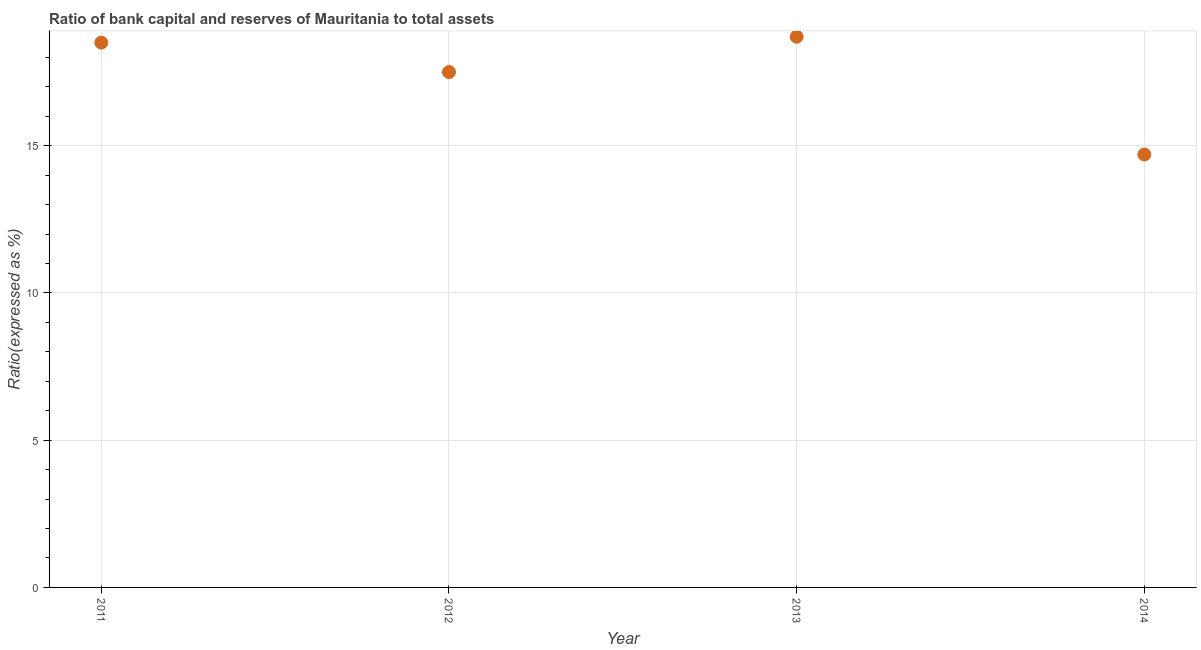Across all years, what is the minimum bank capital to assets ratio?
Offer a terse response. 14.7. In which year was the bank capital to assets ratio maximum?
Your response must be concise. 2013. In which year was the bank capital to assets ratio minimum?
Ensure brevity in your answer.  2014. What is the sum of the bank capital to assets ratio?
Make the answer very short. 69.4. What is the difference between the bank capital to assets ratio in 2012 and 2014?
Provide a succinct answer. 2.8. What is the average bank capital to assets ratio per year?
Provide a succinct answer. 17.35. What is the median bank capital to assets ratio?
Provide a short and direct response. 18. What is the ratio of the bank capital to assets ratio in 2011 to that in 2013?
Provide a short and direct response. 0.99. Is the bank capital to assets ratio in 2012 less than that in 2014?
Offer a terse response. No. Is the difference between the bank capital to assets ratio in 2011 and 2014 greater than the difference between any two years?
Make the answer very short. No. What is the difference between the highest and the second highest bank capital to assets ratio?
Make the answer very short. 0.2. In how many years, is the bank capital to assets ratio greater than the average bank capital to assets ratio taken over all years?
Provide a short and direct response. 3. How many years are there in the graph?
Offer a very short reply. 4. Are the values on the major ticks of Y-axis written in scientific E-notation?
Provide a short and direct response. No. Does the graph contain grids?
Make the answer very short. Yes. What is the title of the graph?
Keep it short and to the point. Ratio of bank capital and reserves of Mauritania to total assets. What is the label or title of the Y-axis?
Offer a terse response. Ratio(expressed as %). What is the Ratio(expressed as %) in 2011?
Ensure brevity in your answer.  18.5. What is the difference between the Ratio(expressed as %) in 2011 and 2012?
Ensure brevity in your answer.  1. What is the difference between the Ratio(expressed as %) in 2011 and 2013?
Make the answer very short. -0.2. What is the difference between the Ratio(expressed as %) in 2012 and 2014?
Your response must be concise. 2.8. What is the ratio of the Ratio(expressed as %) in 2011 to that in 2012?
Keep it short and to the point. 1.06. What is the ratio of the Ratio(expressed as %) in 2011 to that in 2013?
Ensure brevity in your answer.  0.99. What is the ratio of the Ratio(expressed as %) in 2011 to that in 2014?
Your answer should be compact. 1.26. What is the ratio of the Ratio(expressed as %) in 2012 to that in 2013?
Offer a very short reply. 0.94. What is the ratio of the Ratio(expressed as %) in 2012 to that in 2014?
Your answer should be very brief. 1.19. What is the ratio of the Ratio(expressed as %) in 2013 to that in 2014?
Offer a very short reply. 1.27. 